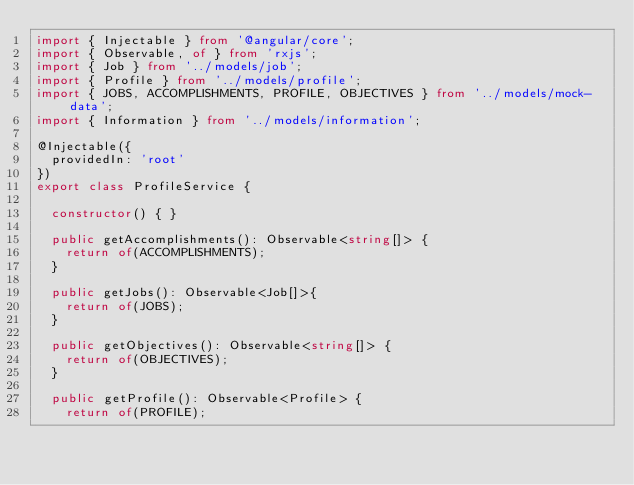<code> <loc_0><loc_0><loc_500><loc_500><_TypeScript_>import { Injectable } from '@angular/core';
import { Observable, of } from 'rxjs';
import { Job } from '../models/job';
import { Profile } from '../models/profile';
import { JOBS, ACCOMPLISHMENTS, PROFILE, OBJECTIVES } from '../models/mock-data';
import { Information } from '../models/information';

@Injectable({
  providedIn: 'root'
})
export class ProfileService {

  constructor() { }

  public getAccomplishments(): Observable<string[]> {
    return of(ACCOMPLISHMENTS);
  }

  public getJobs(): Observable<Job[]>{
    return of(JOBS);
  }

  public getObjectives(): Observable<string[]> {
    return of(OBJECTIVES);
  }

  public getProfile(): Observable<Profile> {
    return of(PROFILE);</code> 